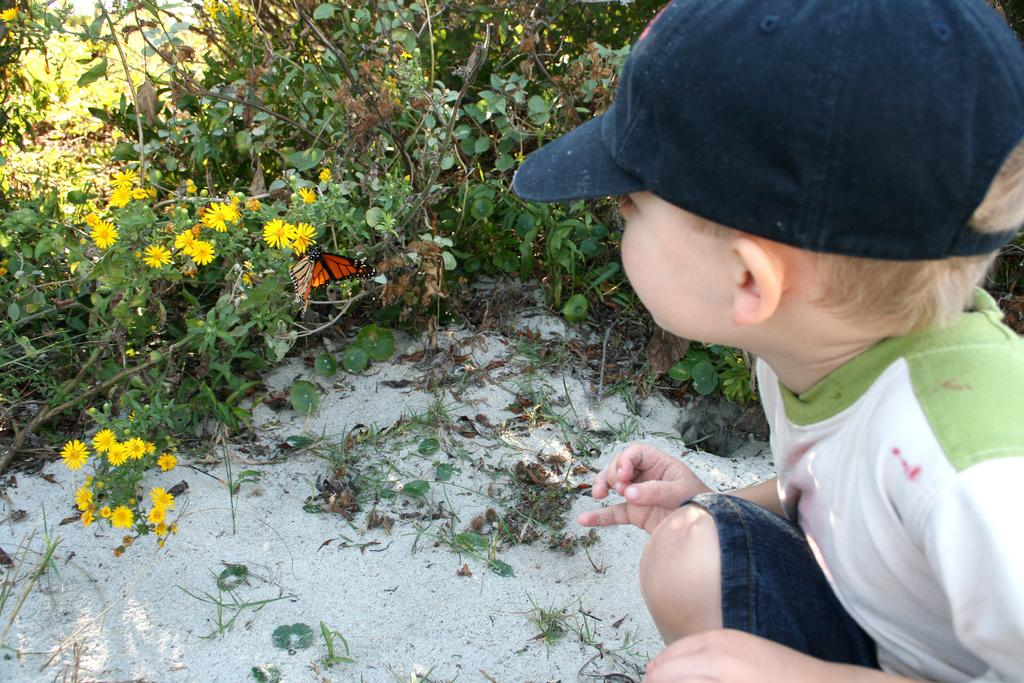What is the main subject of the image? The main subject of the image is a child. Can you describe the child's attire? The child is wearing a cap. What type of plants can be seen in the image? There are yellow flower plants in the image. What other living creature is present in the image? A butterfly is present in the image. What type of border is visible around the child in the image? There is no border visible around the child in the image. What is the child eating for lunch in the image? The image does not show the child eating lunch, so it cannot be determined from the image. 